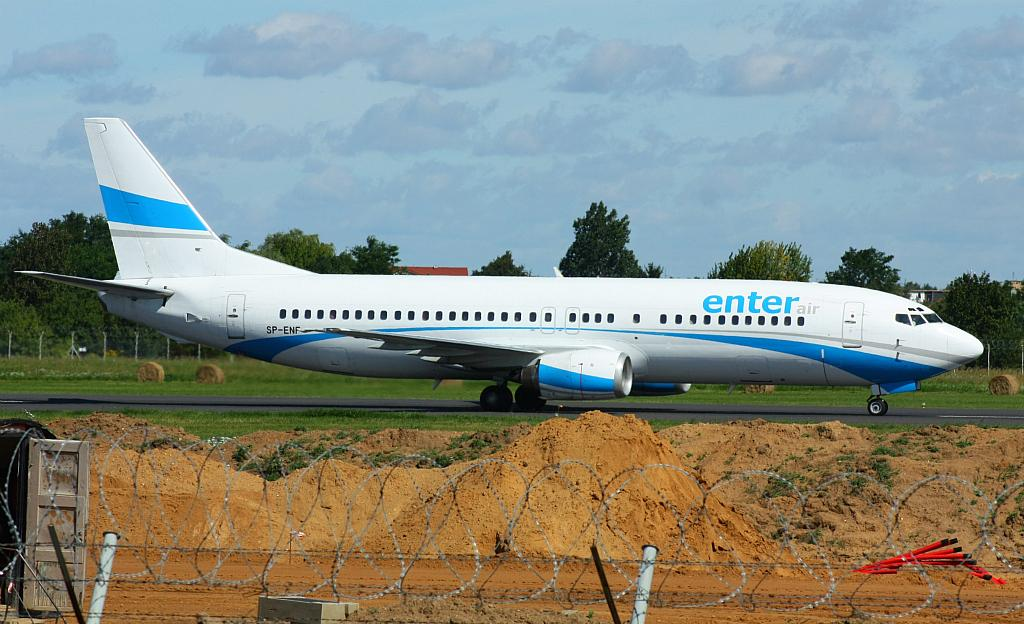<image>
Offer a succinct explanation of the picture presented. An airplane with the logo enterair on the side. 